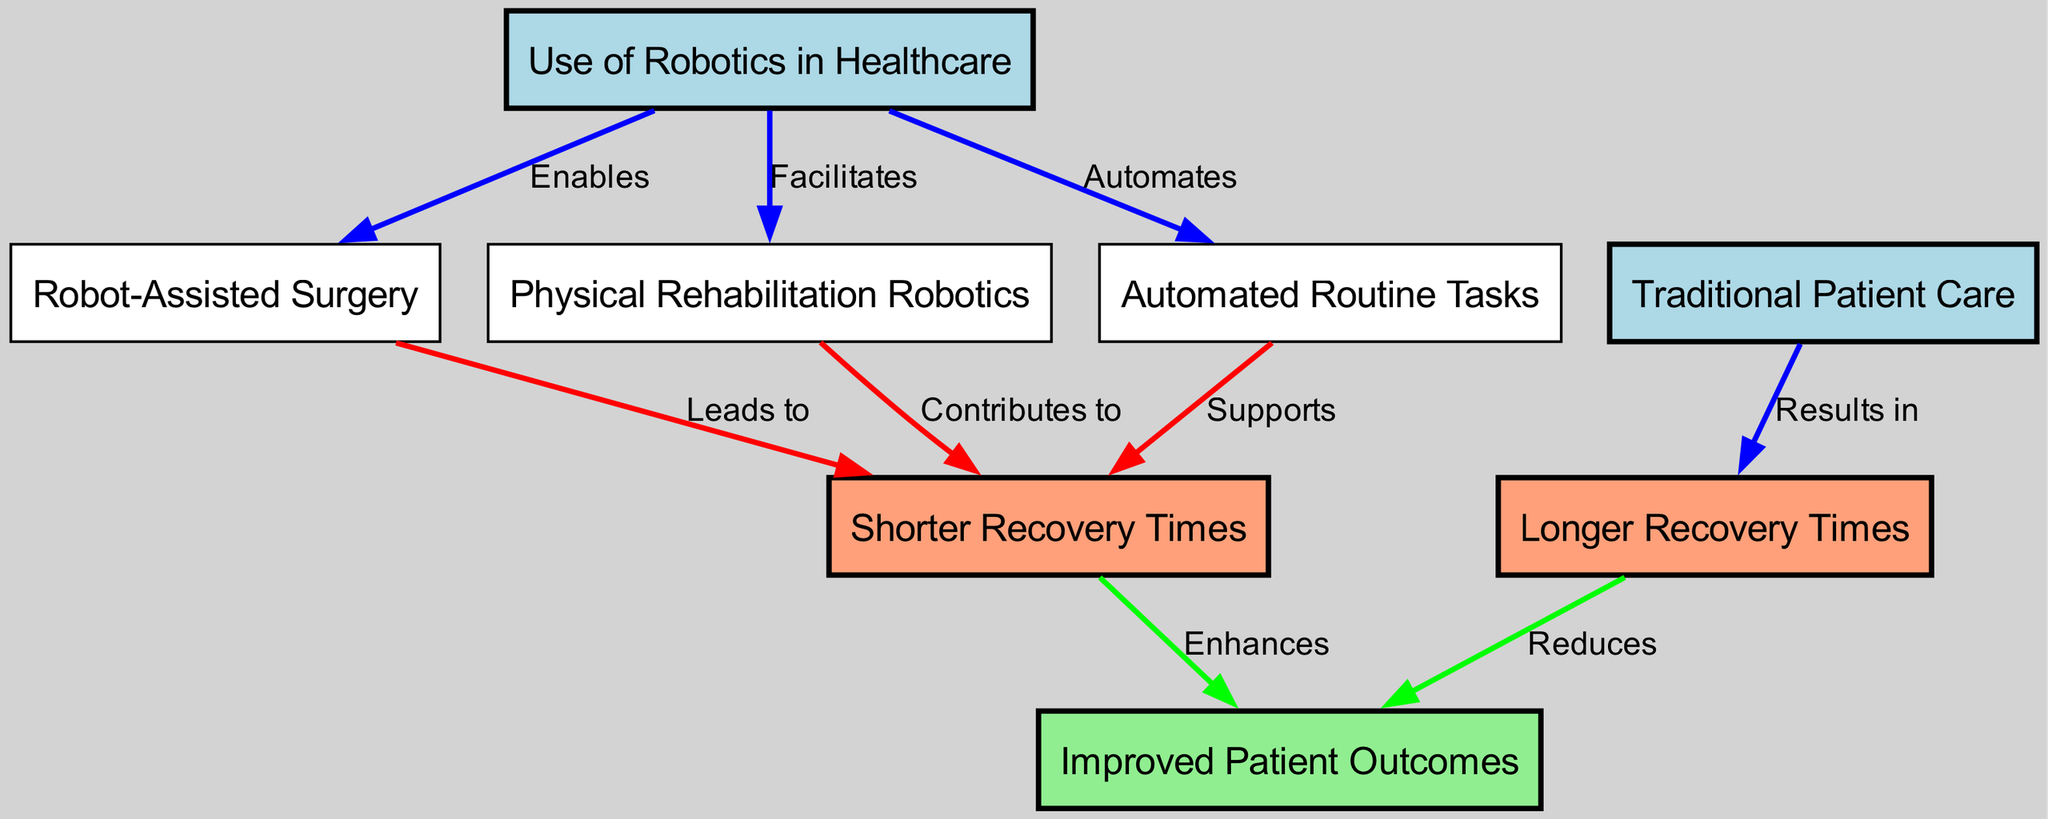What is the title of the first node in the diagram? The first node in the diagram is labeled "Use of Robotics in Healthcare." This is determined by identifying the nodes listed in the diagram and checking the titles assigned to each.
Answer: Use of Robotics in Healthcare How many relationships (edges) are depicted in total? The diagram consists of eight edges connecting the nodes. This is calculated by counting all the edges that connect pairs of nodes based on the provided edges data, which lists these connections clearly.
Answer: Eight What does "robot-assisted surgery" lead to? The diagram shows that "robot-assisted surgery" leads to "shorter recovery" times. To find this, I look at the edges stemming from the "robot-assisted surgery" node, specifically checking the one labeled "Leads to."
Answer: Shorter recovery times Which node is connected to "longer recovery" by the label "Results in"? The node "traditional patient care" is connected to "longer recovery" with the label "Results in." This can be found by examining the edges to see which edge links to "longer recovery" and checking its source node.
Answer: Traditional Patient Care What does a shorter recovery time enhance? According to the diagram, "shorter recovery" enhances "improved patient outcomes." This information is obtained by identifying the target node of the edge that originates from "shorter recovery" and confirming what it connects to.
Answer: Improved Patient Outcomes Which type of care results in longer recovery times? The diagram indicates that "traditional patient care" results in "longer recovery." This is because the edge labeled "Results in" connects the "traditional patient care" node directly to "longer recovery."
Answer: Traditional Patient Care How does "physical rehabilitation robotics" contribute to recovery times? "Physical rehabilitation robotics" contributes to "shorter recovery" times, as stated in the connection between these two nodes in the diagram, marked by the edge labeled "Contributes to."
Answer: Shorter Recovery Times What color is used for the node "patient outcomes"? The node "patient outcomes" is colored light green according to the diagram’s specifications for different node colors based on their categories. This is identified by the attributes assigned to each node in the rendering rules.
Answer: Light Green 